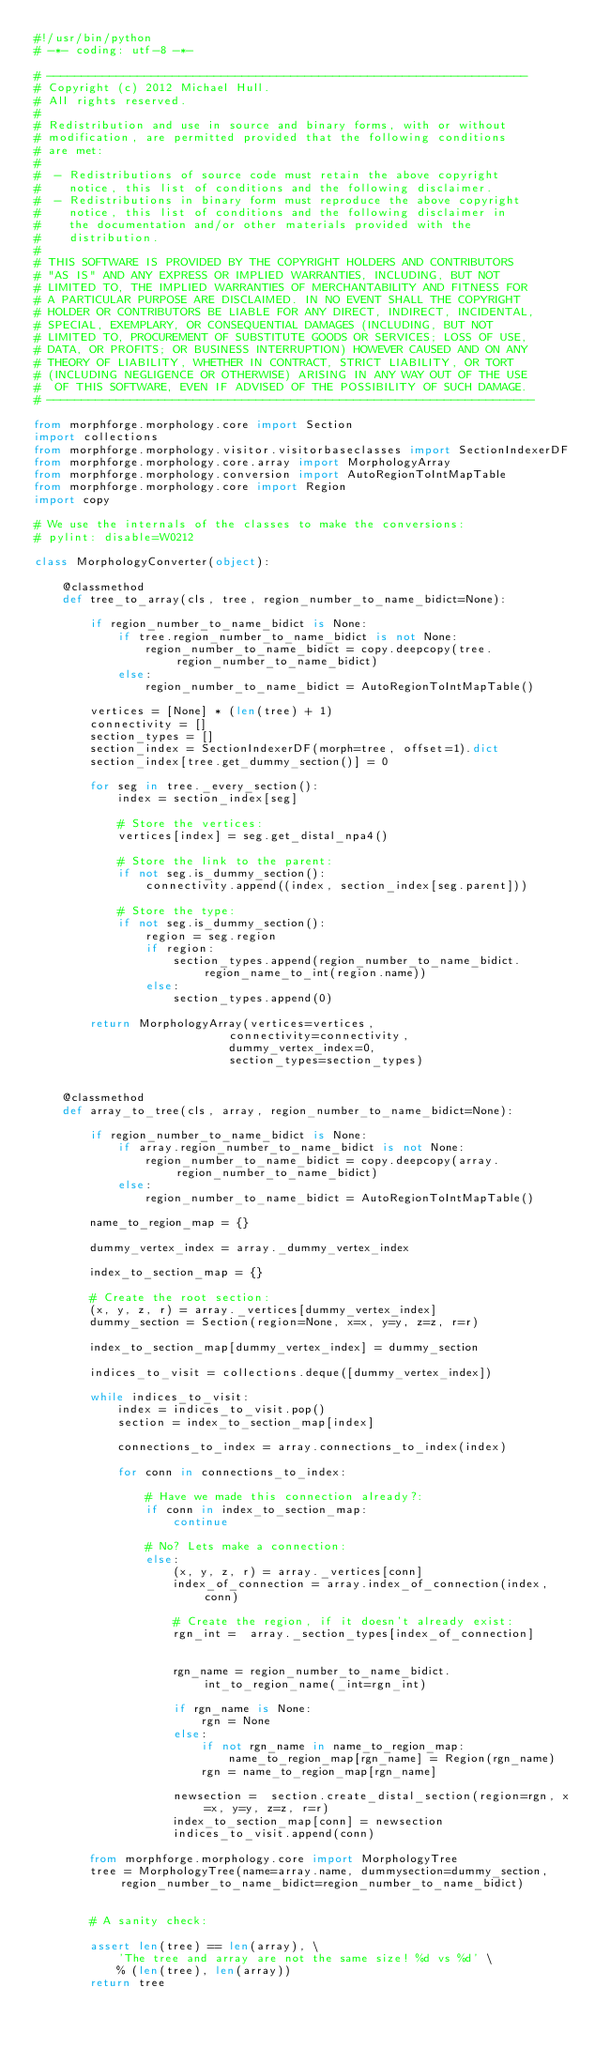<code> <loc_0><loc_0><loc_500><loc_500><_Python_>#!/usr/bin/python
# -*- coding: utf-8 -*-

# ---------------------------------------------------------------------
# Copyright (c) 2012 Michael Hull.
# All rights reserved.
#
# Redistribution and use in source and binary forms, with or without
# modification, are permitted provided that the following conditions
# are met:
#
#  - Redistributions of source code must retain the above copyright
#    notice, this list of conditions and the following disclaimer.
#  - Redistributions in binary form must reproduce the above copyright
#    notice, this list of conditions and the following disclaimer in
#    the documentation and/or other materials provided with the
#    distribution.
#
# THIS SOFTWARE IS PROVIDED BY THE COPYRIGHT HOLDERS AND CONTRIBUTORS
# "AS IS" AND ANY EXPRESS OR IMPLIED WARRANTIES, INCLUDING, BUT NOT
# LIMITED TO, THE IMPLIED WARRANTIES OF MERCHANTABILITY AND FITNESS FOR
# A PARTICULAR PURPOSE ARE DISCLAIMED. IN NO EVENT SHALL THE COPYRIGHT
# HOLDER OR CONTRIBUTORS BE LIABLE FOR ANY DIRECT, INDIRECT, INCIDENTAL,
# SPECIAL, EXEMPLARY, OR CONSEQUENTIAL DAMAGES (INCLUDING, BUT NOT
# LIMITED TO, PROCUREMENT OF SUBSTITUTE GOODS OR SERVICES; LOSS OF USE,
# DATA, OR PROFITS; OR BUSINESS INTERRUPTION) HOWEVER CAUSED AND ON ANY
# THEORY OF LIABILITY, WHETHER IN CONTRACT, STRICT LIABILITY, OR TORT
# (INCLUDING NEGLIGENCE OR OTHERWISE) ARISING IN ANY WAY OUT OF THE USE
#  OF THIS SOFTWARE, EVEN IF ADVISED OF THE POSSIBILITY OF SUCH DAMAGE.
# ----------------------------------------------------------------------

from morphforge.morphology.core import Section
import collections
from morphforge.morphology.visitor.visitorbaseclasses import SectionIndexerDF
from morphforge.morphology.core.array import MorphologyArray
from morphforge.morphology.conversion import AutoRegionToIntMapTable
from morphforge.morphology.core import Region
import copy

# We use the internals of the classes to make the conversions:
# pylint: disable=W0212

class MorphologyConverter(object):

    @classmethod
    def tree_to_array(cls, tree, region_number_to_name_bidict=None):

        if region_number_to_name_bidict is None:
            if tree.region_number_to_name_bidict is not None:
                region_number_to_name_bidict = copy.deepcopy(tree.region_number_to_name_bidict)
            else:
                region_number_to_name_bidict = AutoRegionToIntMapTable()

        vertices = [None] * (len(tree) + 1)
        connectivity = []
        section_types = []
        section_index = SectionIndexerDF(morph=tree, offset=1).dict
        section_index[tree.get_dummy_section()] = 0

        for seg in tree._every_section():
            index = section_index[seg]

            # Store the vertices:
            vertices[index] = seg.get_distal_npa4()

            # Store the link to the parent:
            if not seg.is_dummy_section():
                connectivity.append((index, section_index[seg.parent]))

            # Store the type:
            if not seg.is_dummy_section():
                region = seg.region
                if region:
                    section_types.append(region_number_to_name_bidict.region_name_to_int(region.name))
                else:
                    section_types.append(0)

        return MorphologyArray(vertices=vertices,
                            connectivity=connectivity,
                            dummy_vertex_index=0,
                            section_types=section_types)


    @classmethod
    def array_to_tree(cls, array, region_number_to_name_bidict=None):

        if region_number_to_name_bidict is None:
            if array.region_number_to_name_bidict is not None:
                region_number_to_name_bidict = copy.deepcopy(array.region_number_to_name_bidict)
            else:
                region_number_to_name_bidict = AutoRegionToIntMapTable()

        name_to_region_map = {}

        dummy_vertex_index = array._dummy_vertex_index

        index_to_section_map = {}

        # Create the root section:
        (x, y, z, r) = array._vertices[dummy_vertex_index]
        dummy_section = Section(region=None, x=x, y=y, z=z, r=r)

        index_to_section_map[dummy_vertex_index] = dummy_section

        indices_to_visit = collections.deque([dummy_vertex_index])

        while indices_to_visit:
            index = indices_to_visit.pop()
            section = index_to_section_map[index]

            connections_to_index = array.connections_to_index(index)

            for conn in connections_to_index:

                # Have we made this connection already?:
                if conn in index_to_section_map:
                    continue

                # No? Lets make a connection:
                else:
                    (x, y, z, r) = array._vertices[conn]
                    index_of_connection = array.index_of_connection(index, conn)

                    # Create the region, if it doesn't already exist:
                    rgn_int =  array._section_types[index_of_connection]


                    rgn_name = region_number_to_name_bidict.int_to_region_name(_int=rgn_int)

                    if rgn_name is None:
                        rgn = None
                    else:
                        if not rgn_name in name_to_region_map:
                            name_to_region_map[rgn_name] = Region(rgn_name)
                        rgn = name_to_region_map[rgn_name]

                    newsection =  section.create_distal_section(region=rgn, x=x, y=y, z=z, r=r)
                    index_to_section_map[conn] = newsection
                    indices_to_visit.append(conn)

        from morphforge.morphology.core import MorphologyTree
        tree = MorphologyTree(name=array.name, dummysection=dummy_section, region_number_to_name_bidict=region_number_to_name_bidict)


        # A sanity check:

        assert len(tree) == len(array), \
            'The tree and array are not the same size! %d vs %d' \
            % (len(tree), len(array))
        return tree


</code> 